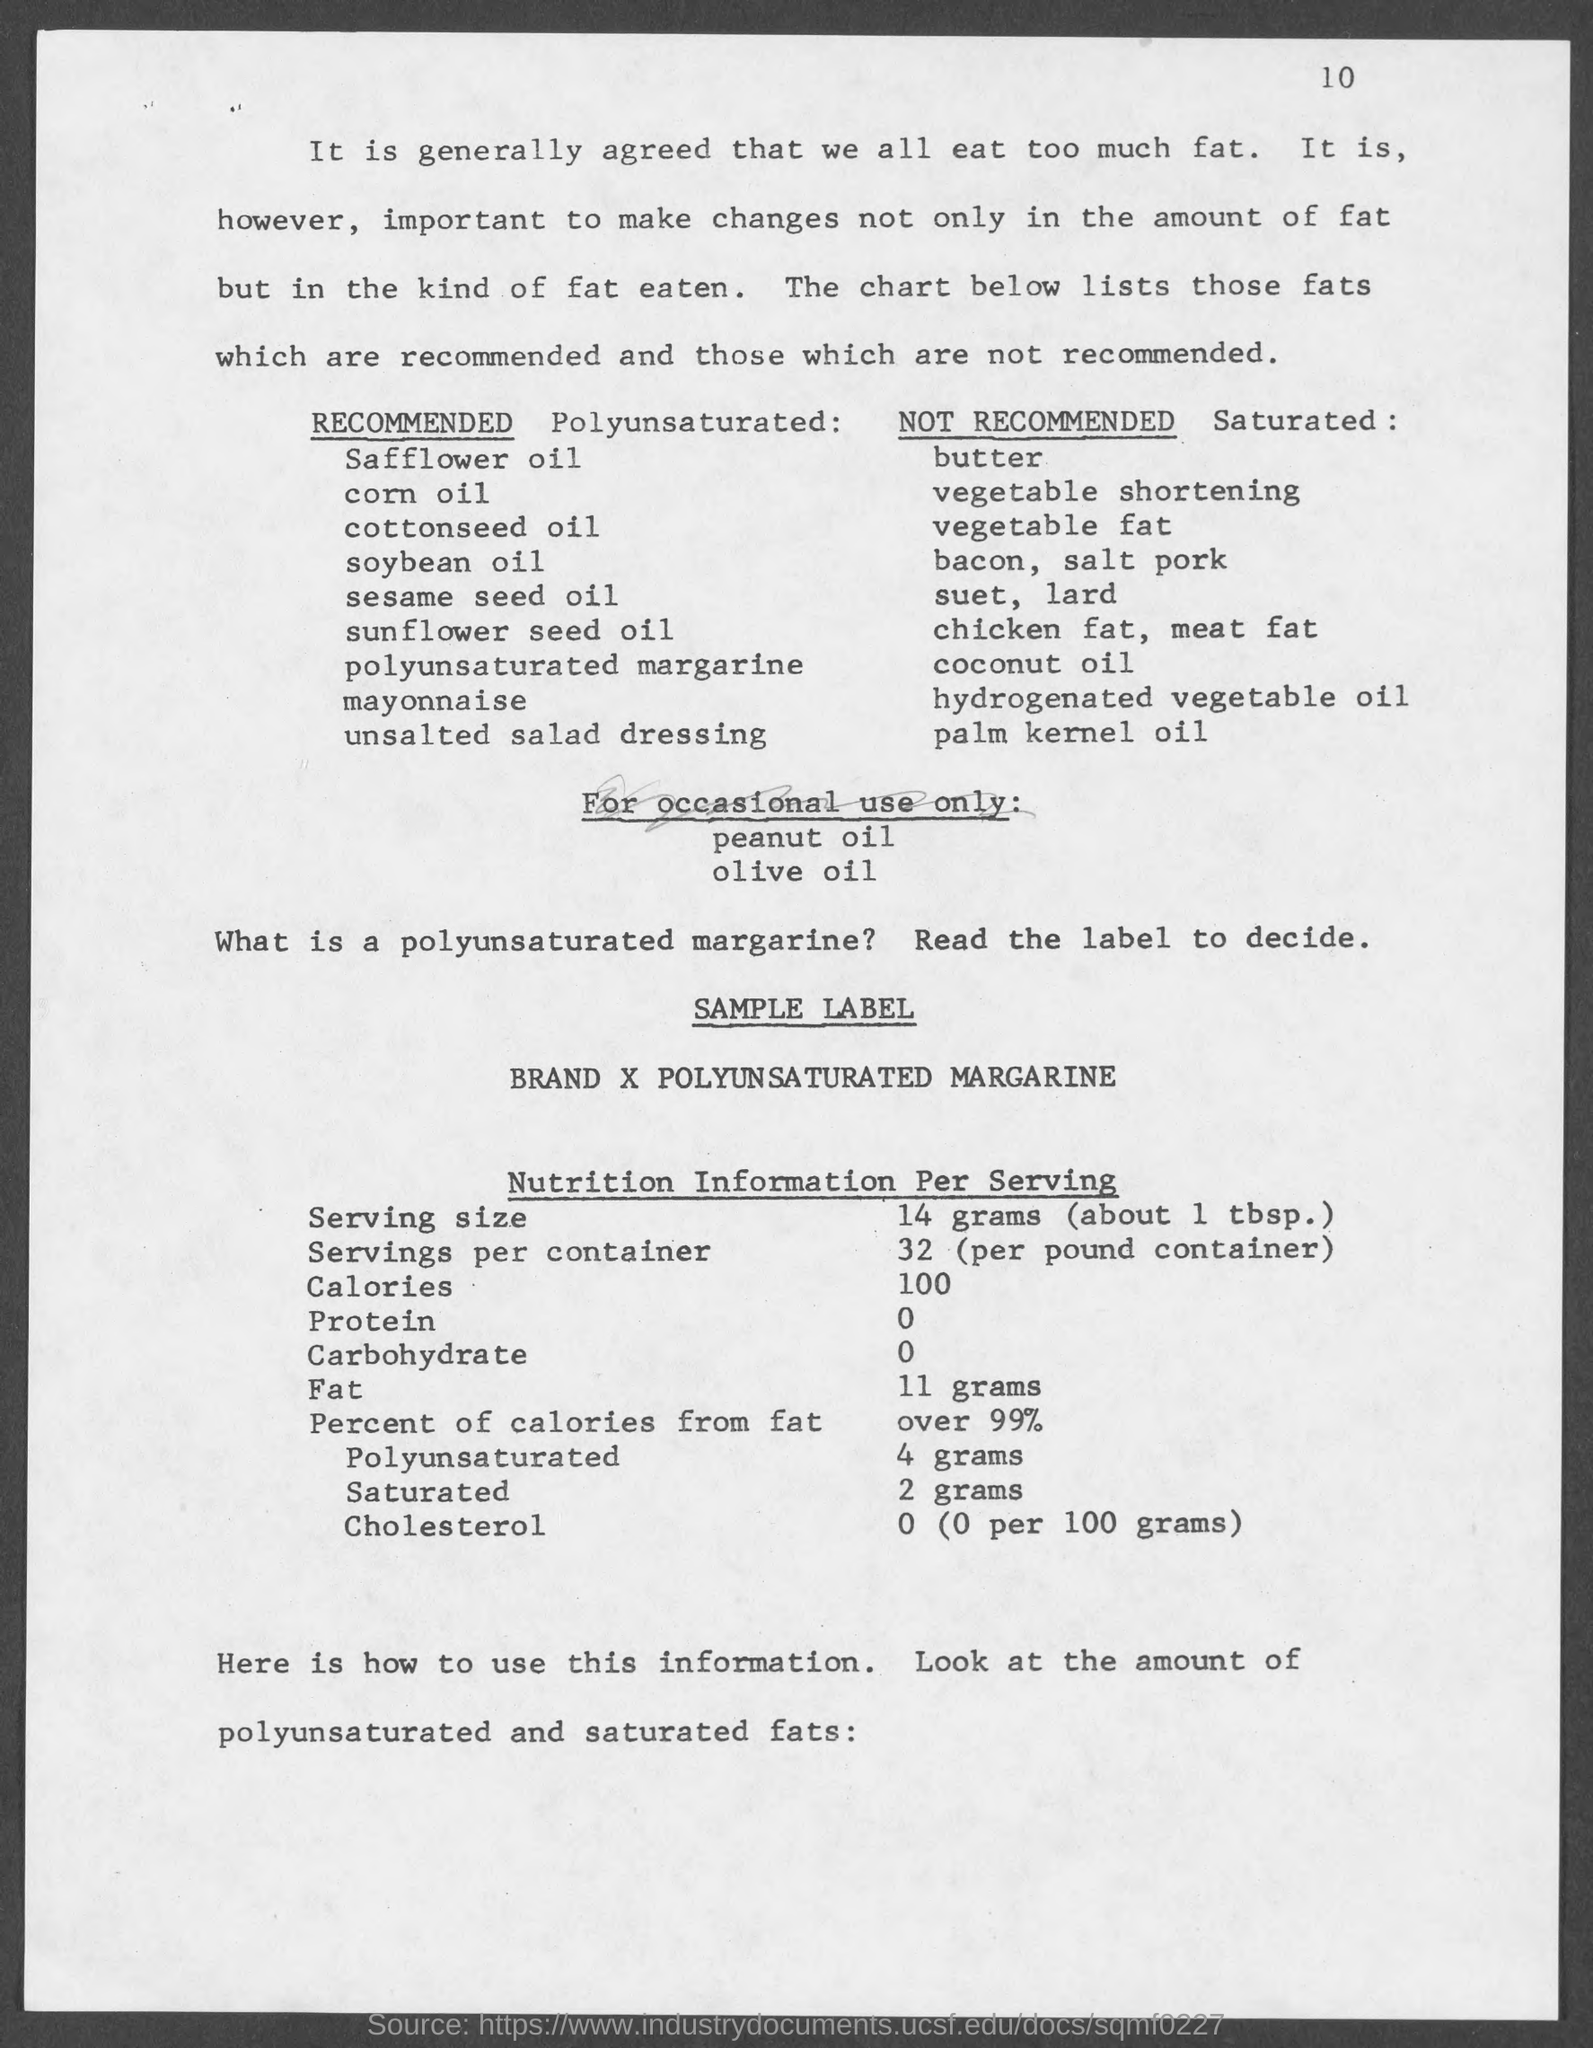What is the page number at top of the page?
Your response must be concise. 10. 